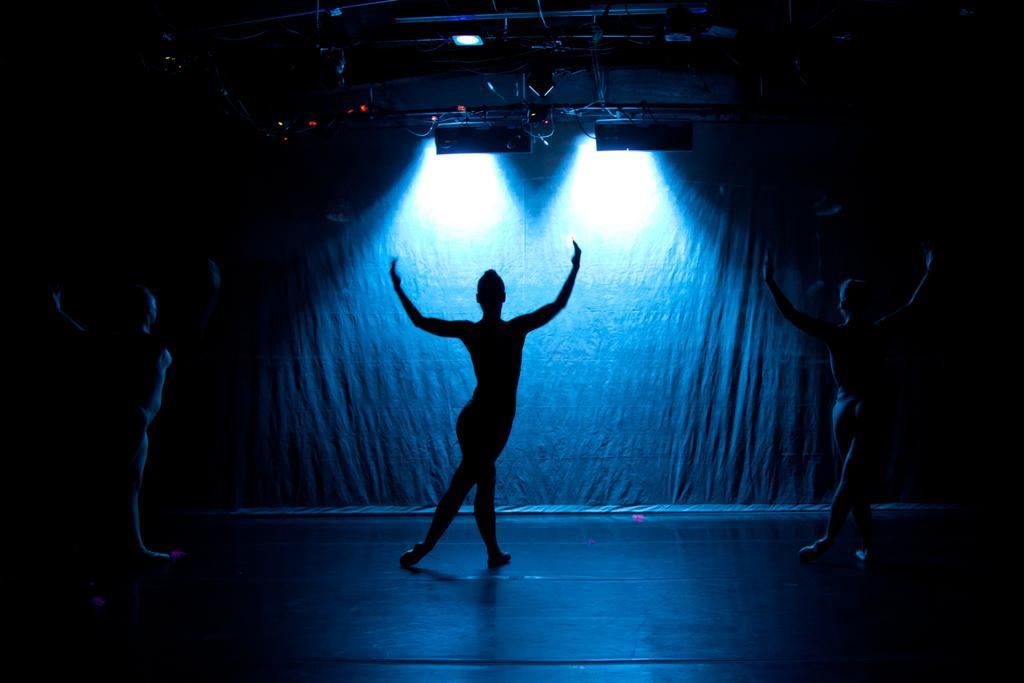How would you summarize this image in a sentence or two? In this image I can see the dark picture in which I can see the floor, three persons dancing on the floor, few metal rods and few lights to the rods. 